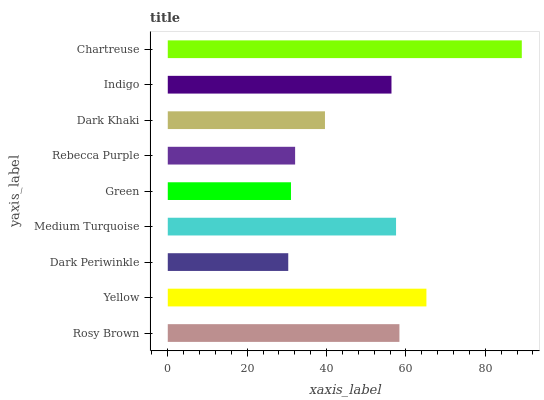Is Dark Periwinkle the minimum?
Answer yes or no. Yes. Is Chartreuse the maximum?
Answer yes or no. Yes. Is Yellow the minimum?
Answer yes or no. No. Is Yellow the maximum?
Answer yes or no. No. Is Yellow greater than Rosy Brown?
Answer yes or no. Yes. Is Rosy Brown less than Yellow?
Answer yes or no. Yes. Is Rosy Brown greater than Yellow?
Answer yes or no. No. Is Yellow less than Rosy Brown?
Answer yes or no. No. Is Indigo the high median?
Answer yes or no. Yes. Is Indigo the low median?
Answer yes or no. Yes. Is Yellow the high median?
Answer yes or no. No. Is Medium Turquoise the low median?
Answer yes or no. No. 